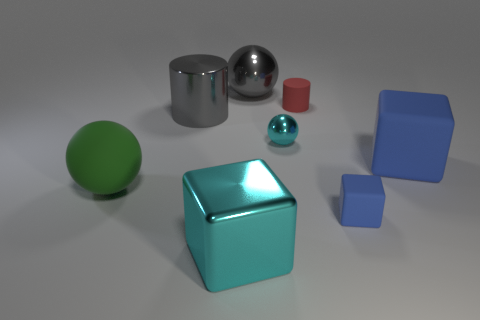Add 1 large yellow matte things. How many objects exist? 9 Subtract 1 cylinders. How many cylinders are left? 1 Subtract all small red matte things. Subtract all rubber balls. How many objects are left? 6 Add 5 shiny cylinders. How many shiny cylinders are left? 6 Add 6 cyan metal objects. How many cyan metal objects exist? 8 Subtract all blue cubes. How many cubes are left? 1 Subtract all tiny balls. How many balls are left? 2 Subtract 1 gray cylinders. How many objects are left? 7 Subtract all balls. How many objects are left? 5 Subtract all red balls. Subtract all green cylinders. How many balls are left? 3 